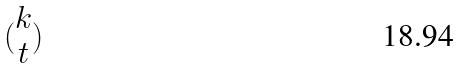Convert formula to latex. <formula><loc_0><loc_0><loc_500><loc_500>( \begin{matrix} k \\ t \end{matrix} )</formula> 